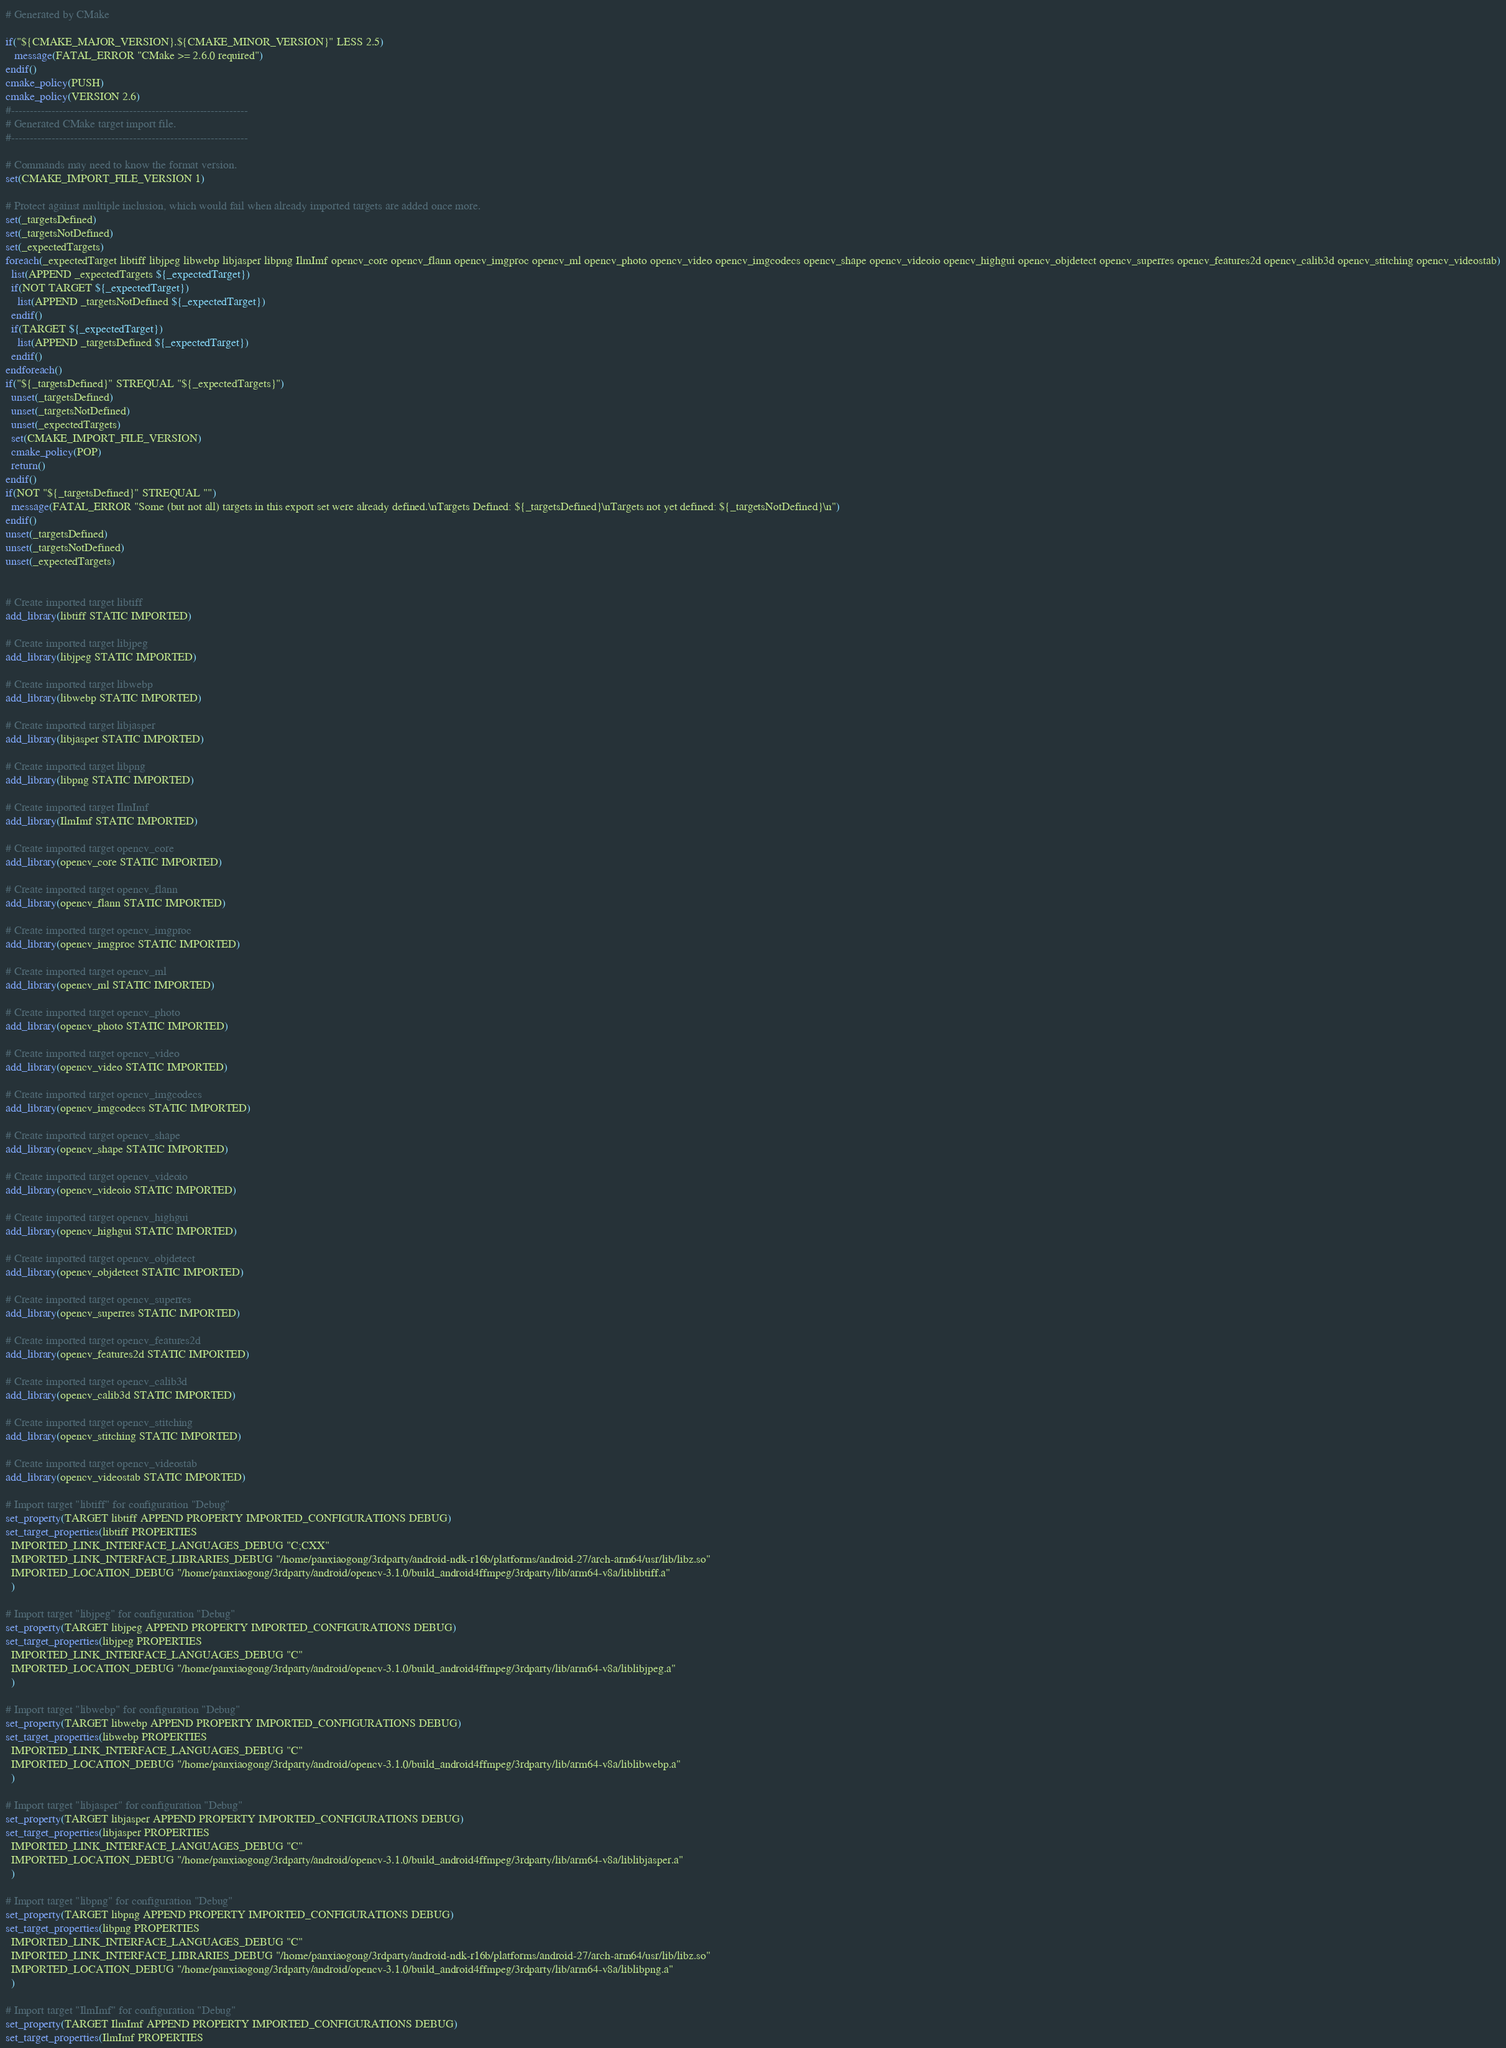<code> <loc_0><loc_0><loc_500><loc_500><_CMake_># Generated by CMake

if("${CMAKE_MAJOR_VERSION}.${CMAKE_MINOR_VERSION}" LESS 2.5)
   message(FATAL_ERROR "CMake >= 2.6.0 required")
endif()
cmake_policy(PUSH)
cmake_policy(VERSION 2.6)
#----------------------------------------------------------------
# Generated CMake target import file.
#----------------------------------------------------------------

# Commands may need to know the format version.
set(CMAKE_IMPORT_FILE_VERSION 1)

# Protect against multiple inclusion, which would fail when already imported targets are added once more.
set(_targetsDefined)
set(_targetsNotDefined)
set(_expectedTargets)
foreach(_expectedTarget libtiff libjpeg libwebp libjasper libpng IlmImf opencv_core opencv_flann opencv_imgproc opencv_ml opencv_photo opencv_video opencv_imgcodecs opencv_shape opencv_videoio opencv_highgui opencv_objdetect opencv_superres opencv_features2d opencv_calib3d opencv_stitching opencv_videostab)
  list(APPEND _expectedTargets ${_expectedTarget})
  if(NOT TARGET ${_expectedTarget})
    list(APPEND _targetsNotDefined ${_expectedTarget})
  endif()
  if(TARGET ${_expectedTarget})
    list(APPEND _targetsDefined ${_expectedTarget})
  endif()
endforeach()
if("${_targetsDefined}" STREQUAL "${_expectedTargets}")
  unset(_targetsDefined)
  unset(_targetsNotDefined)
  unset(_expectedTargets)
  set(CMAKE_IMPORT_FILE_VERSION)
  cmake_policy(POP)
  return()
endif()
if(NOT "${_targetsDefined}" STREQUAL "")
  message(FATAL_ERROR "Some (but not all) targets in this export set were already defined.\nTargets Defined: ${_targetsDefined}\nTargets not yet defined: ${_targetsNotDefined}\n")
endif()
unset(_targetsDefined)
unset(_targetsNotDefined)
unset(_expectedTargets)


# Create imported target libtiff
add_library(libtiff STATIC IMPORTED)

# Create imported target libjpeg
add_library(libjpeg STATIC IMPORTED)

# Create imported target libwebp
add_library(libwebp STATIC IMPORTED)

# Create imported target libjasper
add_library(libjasper STATIC IMPORTED)

# Create imported target libpng
add_library(libpng STATIC IMPORTED)

# Create imported target IlmImf
add_library(IlmImf STATIC IMPORTED)

# Create imported target opencv_core
add_library(opencv_core STATIC IMPORTED)

# Create imported target opencv_flann
add_library(opencv_flann STATIC IMPORTED)

# Create imported target opencv_imgproc
add_library(opencv_imgproc STATIC IMPORTED)

# Create imported target opencv_ml
add_library(opencv_ml STATIC IMPORTED)

# Create imported target opencv_photo
add_library(opencv_photo STATIC IMPORTED)

# Create imported target opencv_video
add_library(opencv_video STATIC IMPORTED)

# Create imported target opencv_imgcodecs
add_library(opencv_imgcodecs STATIC IMPORTED)

# Create imported target opencv_shape
add_library(opencv_shape STATIC IMPORTED)

# Create imported target opencv_videoio
add_library(opencv_videoio STATIC IMPORTED)

# Create imported target opencv_highgui
add_library(opencv_highgui STATIC IMPORTED)

# Create imported target opencv_objdetect
add_library(opencv_objdetect STATIC IMPORTED)

# Create imported target opencv_superres
add_library(opencv_superres STATIC IMPORTED)

# Create imported target opencv_features2d
add_library(opencv_features2d STATIC IMPORTED)

# Create imported target opencv_calib3d
add_library(opencv_calib3d STATIC IMPORTED)

# Create imported target opencv_stitching
add_library(opencv_stitching STATIC IMPORTED)

# Create imported target opencv_videostab
add_library(opencv_videostab STATIC IMPORTED)

# Import target "libtiff" for configuration "Debug"
set_property(TARGET libtiff APPEND PROPERTY IMPORTED_CONFIGURATIONS DEBUG)
set_target_properties(libtiff PROPERTIES
  IMPORTED_LINK_INTERFACE_LANGUAGES_DEBUG "C;CXX"
  IMPORTED_LINK_INTERFACE_LIBRARIES_DEBUG "/home/panxiaogong/3rdparty/android-ndk-r16b/platforms/android-27/arch-arm64/usr/lib/libz.so"
  IMPORTED_LOCATION_DEBUG "/home/panxiaogong/3rdparty/android/opencv-3.1.0/build_android4ffmpeg/3rdparty/lib/arm64-v8a/liblibtiff.a"
  )

# Import target "libjpeg" for configuration "Debug"
set_property(TARGET libjpeg APPEND PROPERTY IMPORTED_CONFIGURATIONS DEBUG)
set_target_properties(libjpeg PROPERTIES
  IMPORTED_LINK_INTERFACE_LANGUAGES_DEBUG "C"
  IMPORTED_LOCATION_DEBUG "/home/panxiaogong/3rdparty/android/opencv-3.1.0/build_android4ffmpeg/3rdparty/lib/arm64-v8a/liblibjpeg.a"
  )

# Import target "libwebp" for configuration "Debug"
set_property(TARGET libwebp APPEND PROPERTY IMPORTED_CONFIGURATIONS DEBUG)
set_target_properties(libwebp PROPERTIES
  IMPORTED_LINK_INTERFACE_LANGUAGES_DEBUG "C"
  IMPORTED_LOCATION_DEBUG "/home/panxiaogong/3rdparty/android/opencv-3.1.0/build_android4ffmpeg/3rdparty/lib/arm64-v8a/liblibwebp.a"
  )

# Import target "libjasper" for configuration "Debug"
set_property(TARGET libjasper APPEND PROPERTY IMPORTED_CONFIGURATIONS DEBUG)
set_target_properties(libjasper PROPERTIES
  IMPORTED_LINK_INTERFACE_LANGUAGES_DEBUG "C"
  IMPORTED_LOCATION_DEBUG "/home/panxiaogong/3rdparty/android/opencv-3.1.0/build_android4ffmpeg/3rdparty/lib/arm64-v8a/liblibjasper.a"
  )

# Import target "libpng" for configuration "Debug"
set_property(TARGET libpng APPEND PROPERTY IMPORTED_CONFIGURATIONS DEBUG)
set_target_properties(libpng PROPERTIES
  IMPORTED_LINK_INTERFACE_LANGUAGES_DEBUG "C"
  IMPORTED_LINK_INTERFACE_LIBRARIES_DEBUG "/home/panxiaogong/3rdparty/android-ndk-r16b/platforms/android-27/arch-arm64/usr/lib/libz.so"
  IMPORTED_LOCATION_DEBUG "/home/panxiaogong/3rdparty/android/opencv-3.1.0/build_android4ffmpeg/3rdparty/lib/arm64-v8a/liblibpng.a"
  )

# Import target "IlmImf" for configuration "Debug"
set_property(TARGET IlmImf APPEND PROPERTY IMPORTED_CONFIGURATIONS DEBUG)
set_target_properties(IlmImf PROPERTIES</code> 